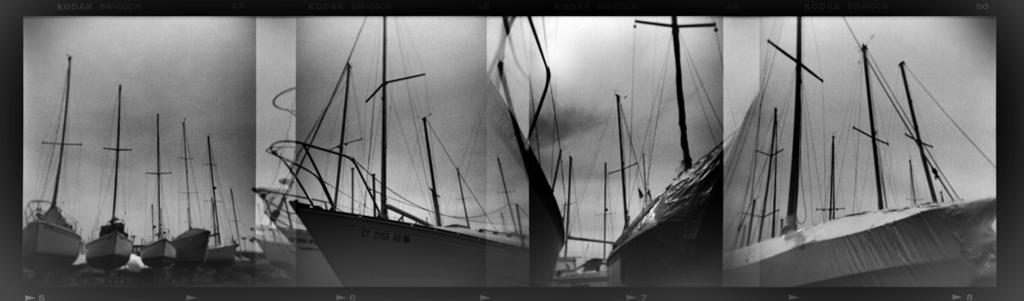What type of vehicles can be seen in the image? There are ships in the image. What is visible in the background of the image? There is sky visible in the background of the image. What type of winter clothing can be seen on the ships in the image? There is no winter clothing present on the ships in the image, as the provided facts do not mention any clothing or winter context. 